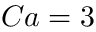Convert formula to latex. <formula><loc_0><loc_0><loc_500><loc_500>C a = 3</formula> 